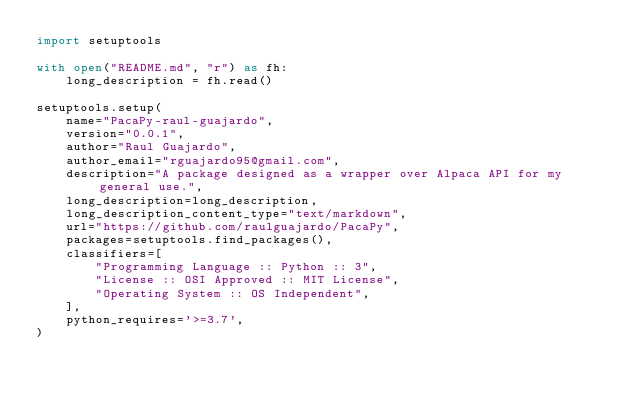Convert code to text. <code><loc_0><loc_0><loc_500><loc_500><_Python_>import setuptools

with open("README.md", "r") as fh:
    long_description = fh.read()

setuptools.setup(
    name="PacaPy-raul-guajardo",
    version="0.0.1",
    author="Raul Guajardo",
    author_email="rguajardo95@gmail.com",
    description="A package designed as a wrapper over Alpaca API for my general use.",
    long_description=long_description,
    long_description_content_type="text/markdown",
    url="https://github.com/raulguajardo/PacaPy",
    packages=setuptools.find_packages(),
    classifiers=[
        "Programming Language :: Python :: 3",
        "License :: OSI Approved :: MIT License",
        "Operating System :: OS Independent",
    ],
    python_requires='>=3.7',
)</code> 